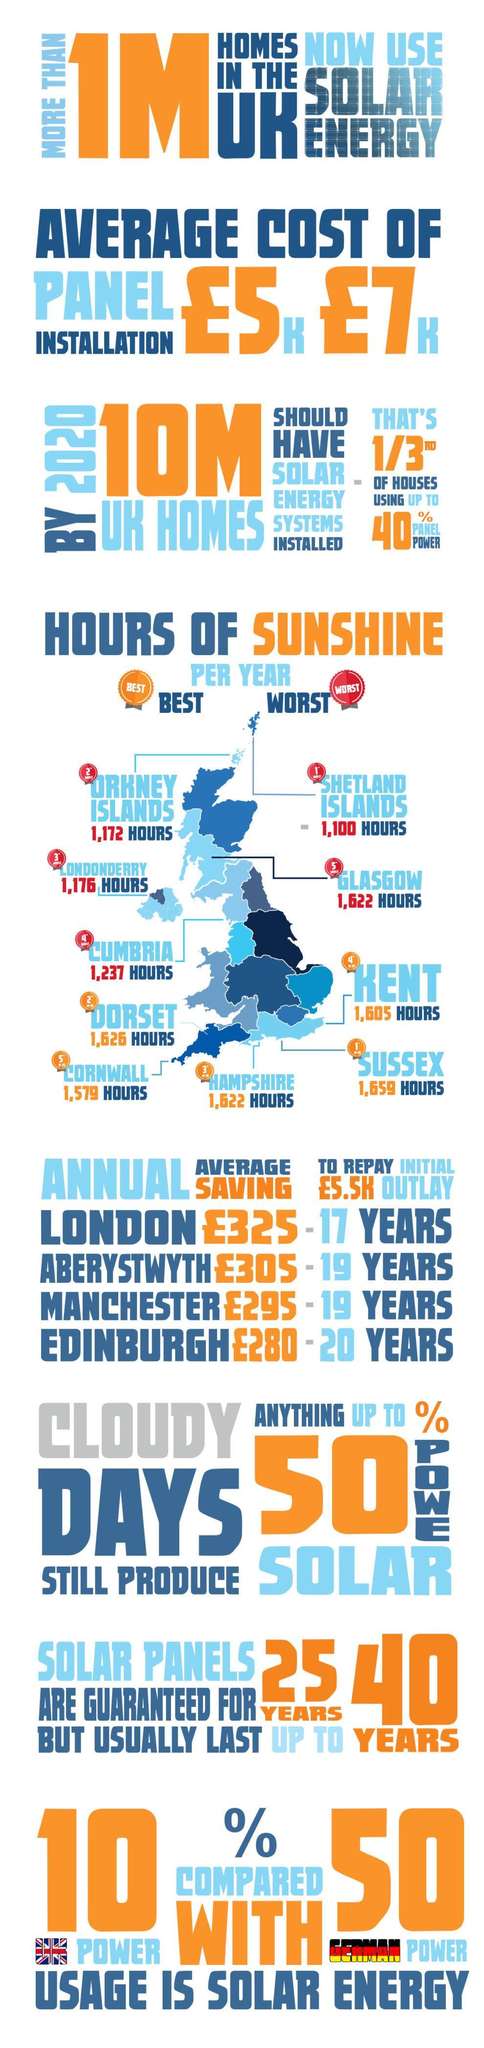What is the initial investment required for solar panel installation(£) in UK?
Answer the question with a short phrase. 5.5k Which county had the least hours of sunshine each year? Shetland Islands Which two cities will be able to be repay the initial outlay in 19 years? Manchester, Aberystwyth What is the percentage of solar energy usage in UK? 10% For how many 'years' can solar panels 'outlive' the guaranteed period? 15 Which city has the highest annual average savings from panel power, and how much(£)? London, 325 Who has a higher solar power consumption, UK or Germany? Germany Which county had the longest hours of sunshine? Sussex What % of solar energy can be produced during cloudy days? 50% How many hours of sunshine did Glasgow County receive each year? 1,622 Which counties are ranked among the top three, for 'worst' hours of sunshine? Shetland Islands, Orkney Islands, Londonderry What is the percentage of solar energy usage in Germany? 50% What 2 categories are the counties divided into, based on the hours of sunshine received per year? Best, Worst How many counties were recorded to have the 'worst' hours of sunshine? 5 What is the guarantee period for power panels? 25 years How many hours of sunshine did Kent County receive each year? 1,605 hours How many 'more' hours of sunshine/year did Dorset receive when compared to Hampshire? 4 By 2020 how many UK homes should have solar energy systems installed? 10m Which counties are ranked among the top three,  for 'best' hours of sunshine per year? Sussex, Dorset, Hampshire For how long do solar panels usually last? 40 years Which of the cities will take the longest to repay the initial outlay? Edinburgh What type of energy is used by more than 1 million homes in the UK? Solar energy Which of the four cities mentioned will be the second to repay the initial outlay and in how many years ? Aberystwyth, 19 How many counties were recorded to have 'best' hours of sunshine? 5 